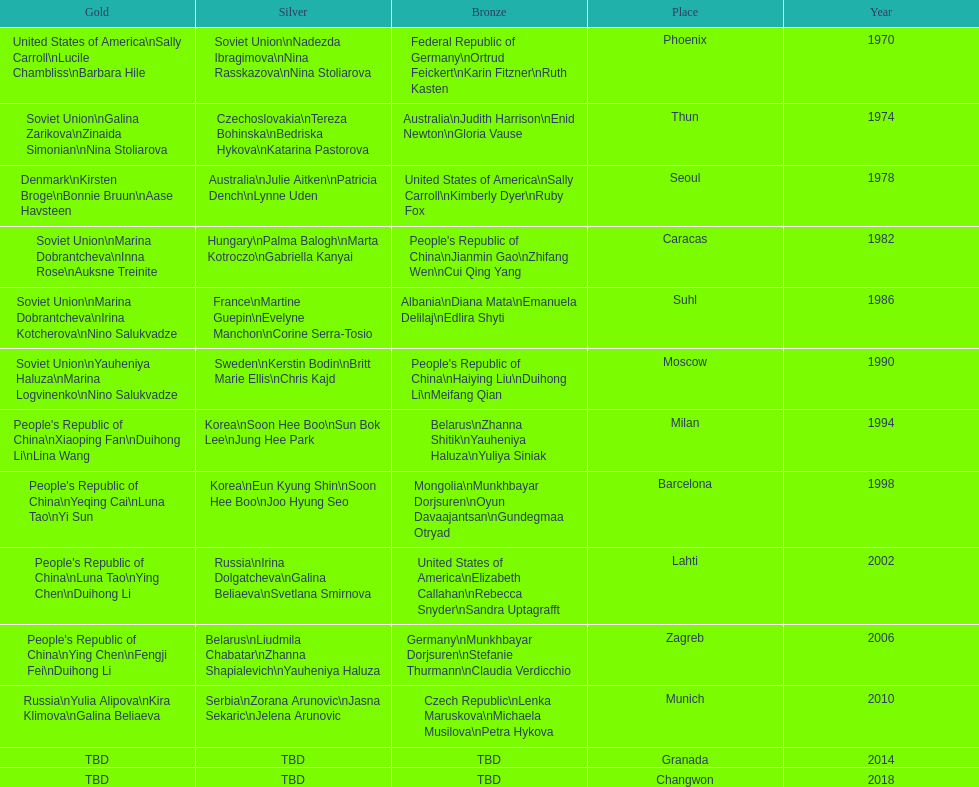Which country is listed the most under the silver column? Korea. 